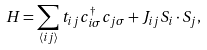<formula> <loc_0><loc_0><loc_500><loc_500>H = \sum _ { \langle i j \rangle } t _ { i j } c _ { i \sigma } ^ { \dagger } c _ { j \sigma } + J _ { i j } { S } _ { i } \cdot { S } _ { j } ,</formula> 